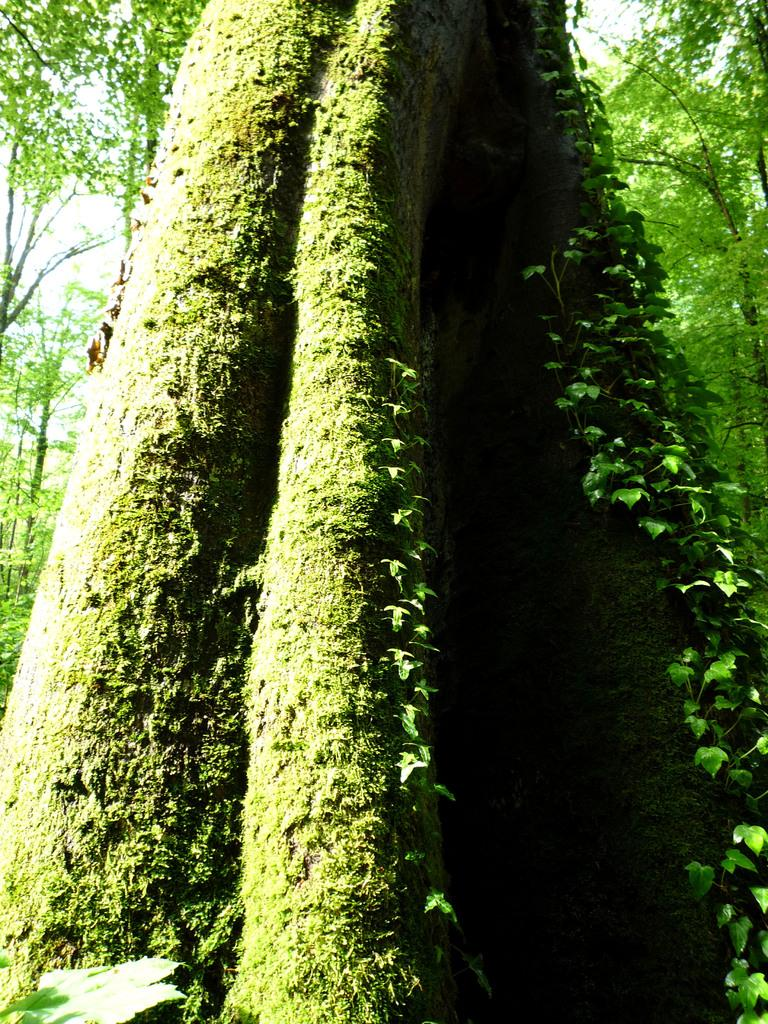What type of vegetation is present in the image? There are many trees and plants in the image. Where are the plants located in the image? The plants are on the right side of the image. What else can be seen on the left side of the image? There are leaves on the left side of the image. What is visible at the top of the image? The sky is visible at the top of the image. What type of bead is hanging from the tree in the image? There is no bead present in the image; it only features trees, plants, leaves, and the sky. What type of amusement can be seen in the image? There is no amusement present in the image; it only features natural elements such as trees, plants, leaves, and the sky. 